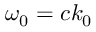<formula> <loc_0><loc_0><loc_500><loc_500>\omega _ { 0 } = c k _ { 0 }</formula> 